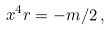Convert formula to latex. <formula><loc_0><loc_0><loc_500><loc_500>x ^ { 4 } r = - m / 2 \, ,</formula> 